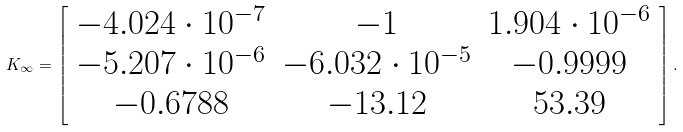Convert formula to latex. <formula><loc_0><loc_0><loc_500><loc_500>K _ { \infty } = \left [ \begin{array} { c c c } - 4 . 0 2 4 \cdot 1 0 ^ { - 7 } & - 1 & 1 . 9 0 4 \cdot 1 0 ^ { - 6 } \\ - 5 . 2 0 7 \cdot 1 0 ^ { - 6 } & - 6 . 0 3 2 \cdot 1 0 ^ { - 5 } & - 0 . 9 9 9 9 \\ - 0 . 6 7 8 8 & - 1 3 . 1 2 & 5 3 . 3 9 \end{array} \right ] .</formula> 